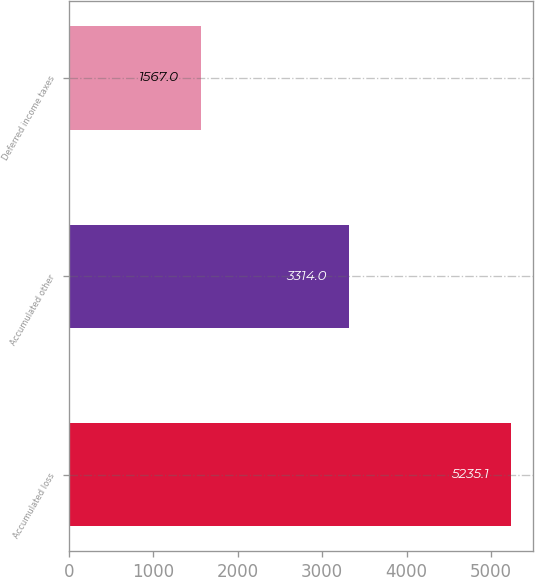<chart> <loc_0><loc_0><loc_500><loc_500><bar_chart><fcel>Accumulated loss<fcel>Accumulated other<fcel>Deferred income taxes<nl><fcel>5235.1<fcel>3314<fcel>1567<nl></chart> 